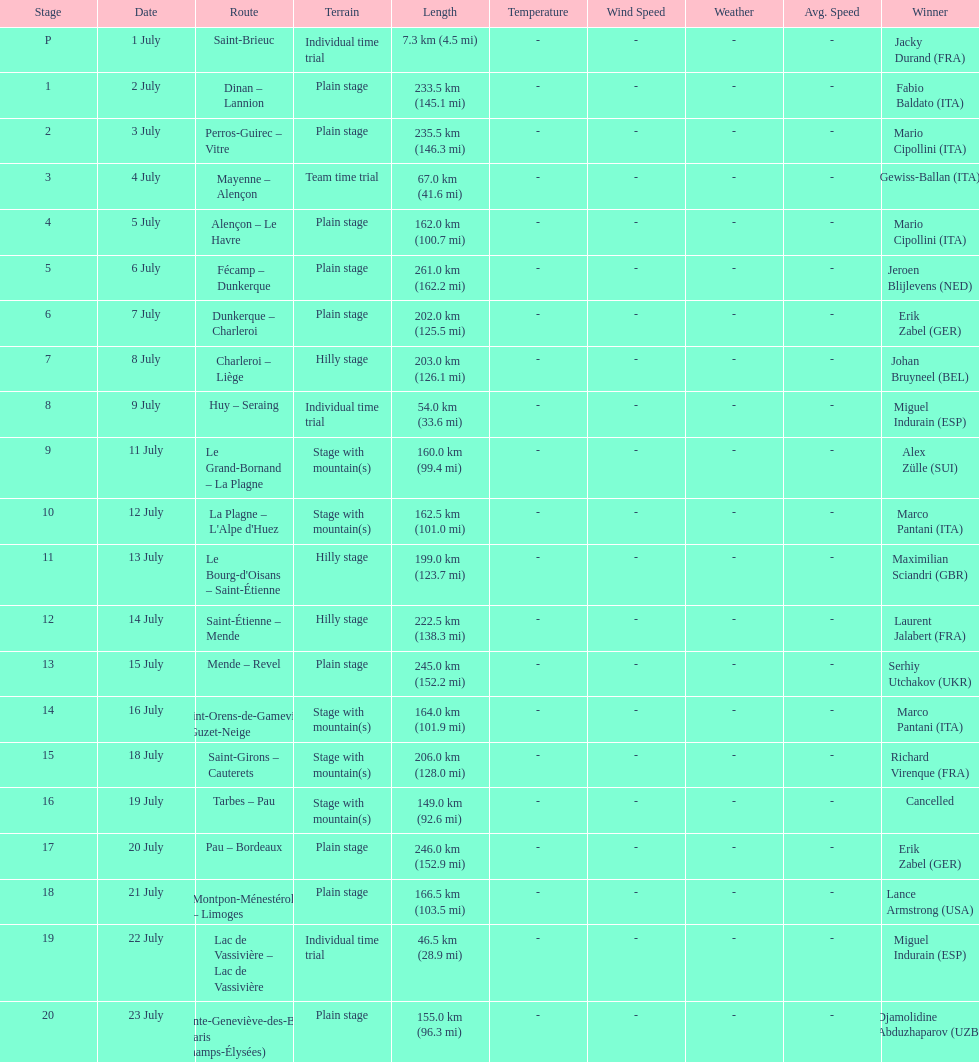Which routes were at least 100 km? Dinan - Lannion, Perros-Guirec - Vitre, Alençon - Le Havre, Fécamp - Dunkerque, Dunkerque - Charleroi, Charleroi - Liège, Le Grand-Bornand - La Plagne, La Plagne - L'Alpe d'Huez, Le Bourg-d'Oisans - Saint-Étienne, Saint-Étienne - Mende, Mende - Revel, Saint-Orens-de-Gameville - Guzet-Neige, Saint-Girons - Cauterets, Tarbes - Pau, Pau - Bordeaux, Montpon-Ménestérol - Limoges, Sainte-Geneviève-des-Bois - Paris (Champs-Élysées). 